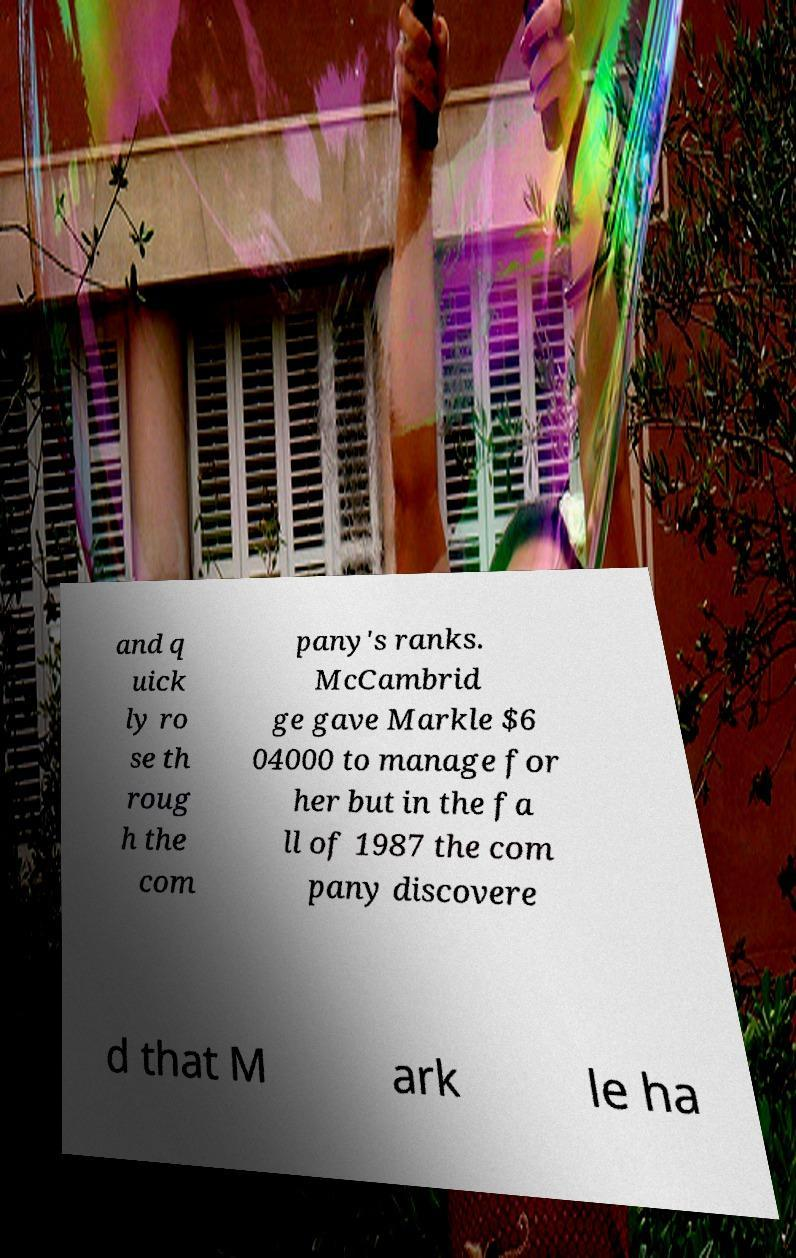What messages or text are displayed in this image? I need them in a readable, typed format. and q uick ly ro se th roug h the com pany's ranks. McCambrid ge gave Markle $6 04000 to manage for her but in the fa ll of 1987 the com pany discovere d that M ark le ha 